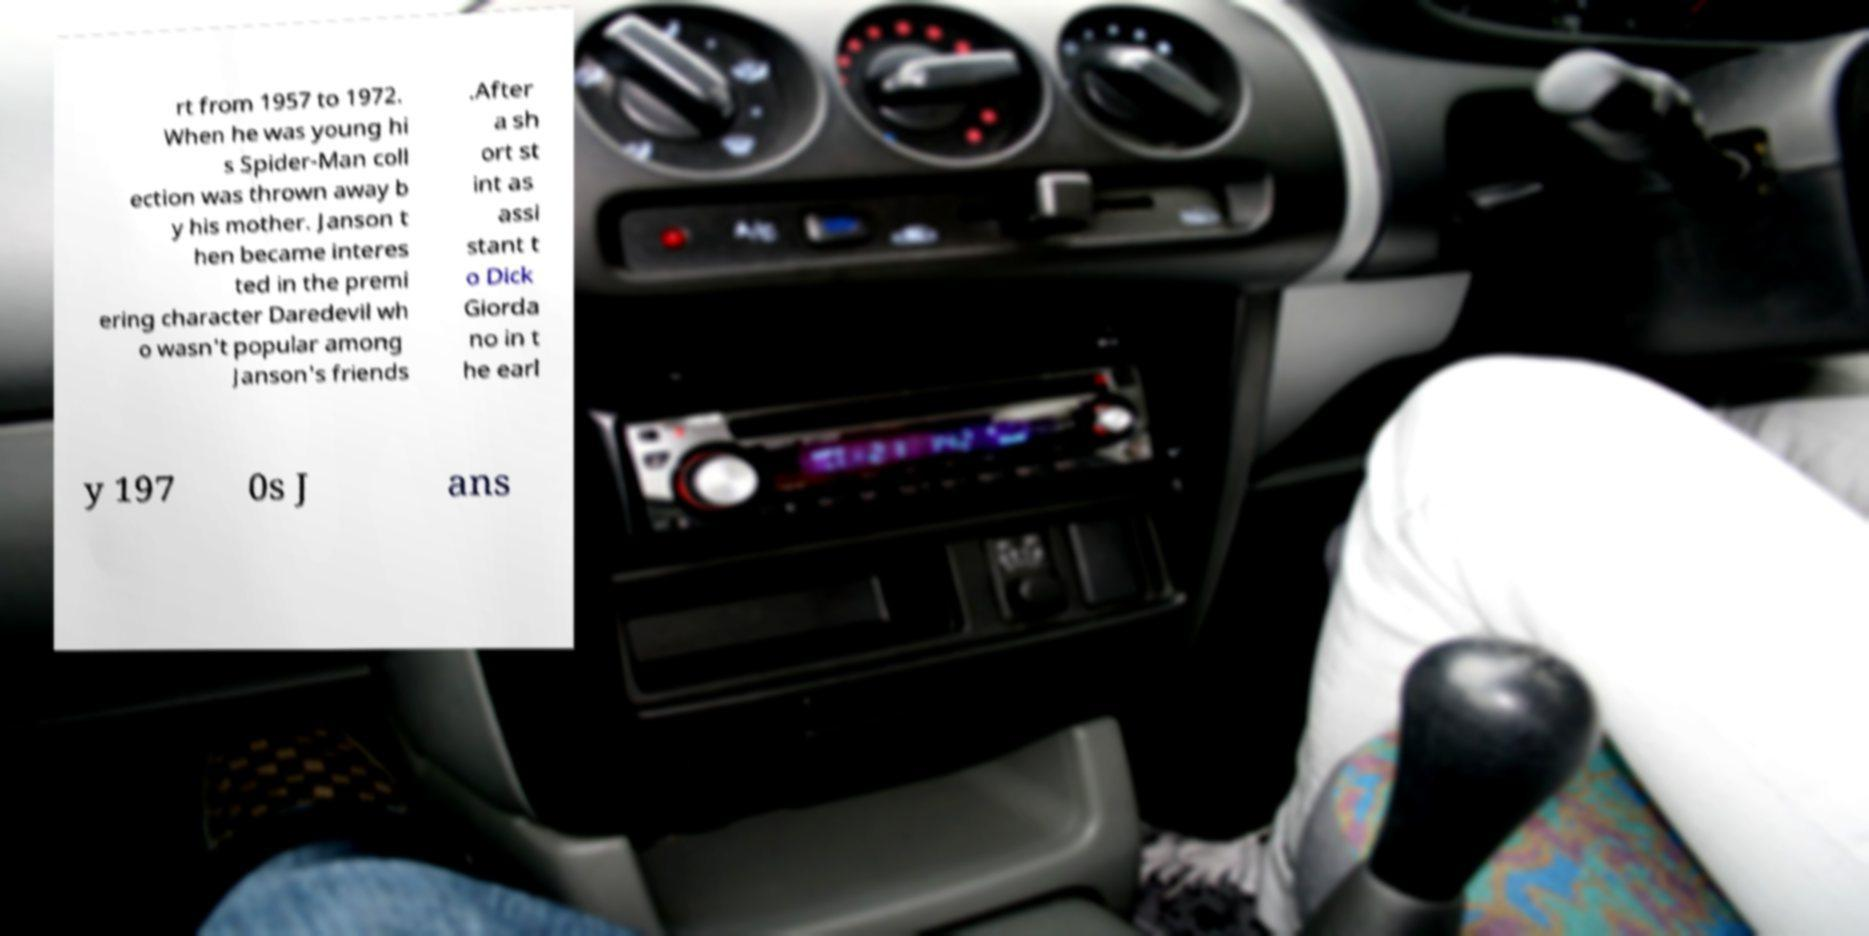There's text embedded in this image that I need extracted. Can you transcribe it verbatim? rt from 1957 to 1972. When he was young hi s Spider-Man coll ection was thrown away b y his mother. Janson t hen became interes ted in the premi ering character Daredevil wh o wasn't popular among Janson's friends .After a sh ort st int as assi stant t o Dick Giorda no in t he earl y 197 0s J ans 